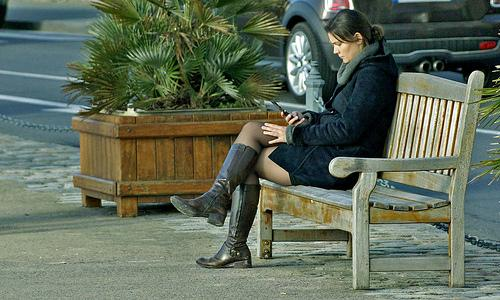What type of road is shown and what is a distinctive feature on the road? It is a paved roadway with three white lines. How is the woman interacting with her cell phone? The woman is holding the cell phone in her right hand and viewing it. Identify the type of plant in the image and describe its color. The plant in the image is a palm plant with green leaves. What color are the woman's boots, and what is she doing? The woman's boots are brown, and she is viewing her cell phone. Is anything blocking the road and if so, what is it? Yes, a chain is blocking the road in front of it. Name the object the woman is interacting with and where it is located. The woman is interacting with a cell phone, which is located in her right hand. Describe the vehicle and where it is parked. The vehicle is a black and dark colored vehicle parked near the sidewalk. How many benches are present and can you describe their main characteristics? There is one bench, which is made of wood and has a weathered appearance. What kind of plant box is in the image and what color is it? There is a wooden plant box which is brown in color. What type of chair is the woman sitting on? The woman is sitting on a wooden bench. 